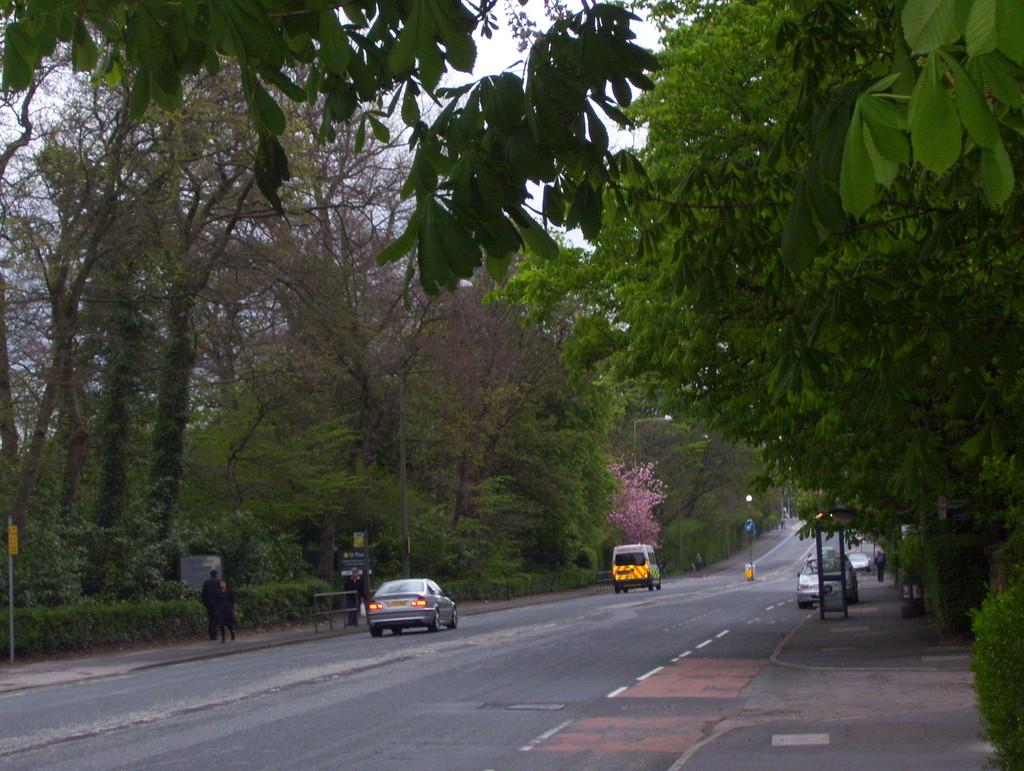What can be seen on the road in the image? There are vehicles on the road in the image. What can be seen on the footpath in the image? There are people on the footpath in the image. What structures are present in the image? There are poles in the image. What type of vegetation is visible in the image? There are trees in the image. What else is present in the image besides the vehicles, people, poles, and trees? There are objects in the image. What is visible in the background of the image? The sky is visible in the background of the image. Where is the place of shame located in the image? There is no place of shame present in the image. What type of seat can be seen on the vehicles in the image? The image does not show the seats inside the vehicles, so it cannot be determined from the image. 